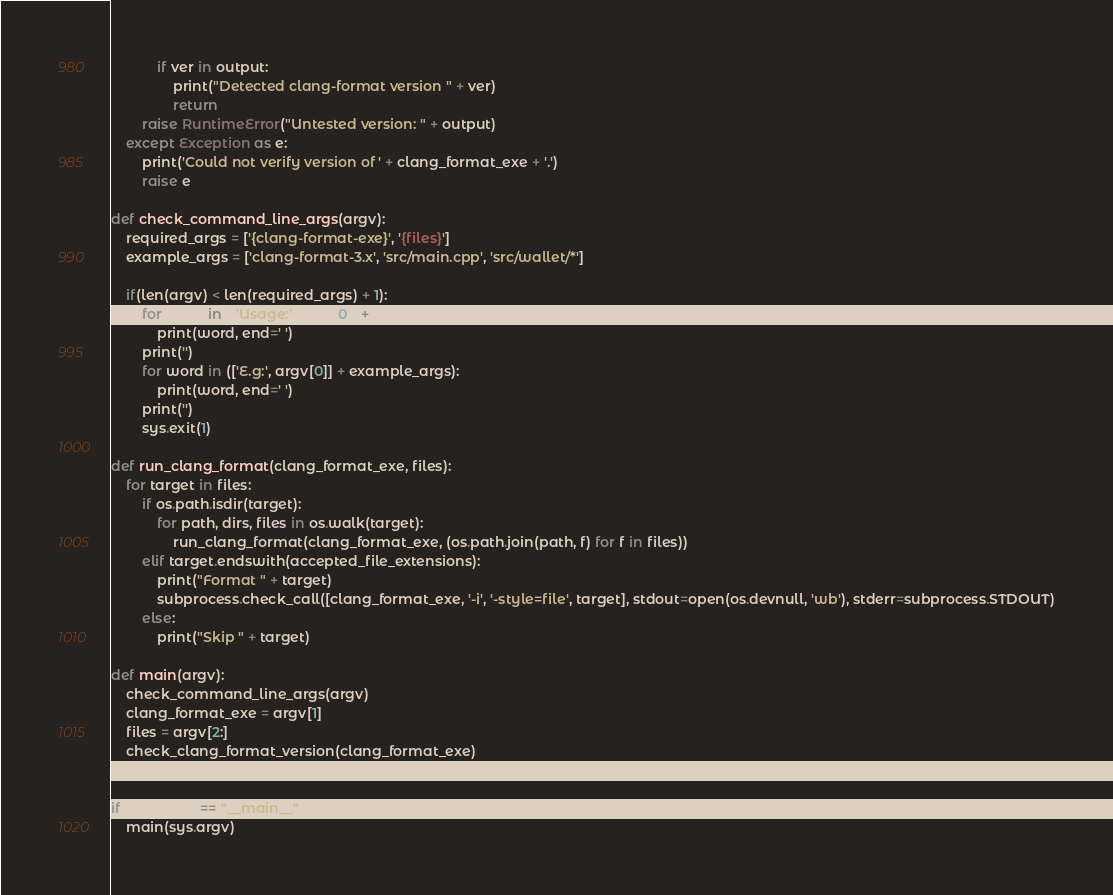Convert code to text. <code><loc_0><loc_0><loc_500><loc_500><_Python_>            if ver in output:
                print("Detected clang-format version " + ver)
                return
        raise RuntimeError("Untested version: " + output)
    except Exception as e:
        print('Could not verify version of ' + clang_format_exe + '.')
        raise e

def check_command_line_args(argv):
    required_args = ['{clang-format-exe}', '{files}']
    example_args = ['clang-format-3.x', 'src/main.cpp', 'src/wallet/*']

    if(len(argv) < len(required_args) + 1):
        for word in (['Usage:', argv[0]] + required_args):
            print(word, end=' ')
        print('')
        for word in (['E.g:', argv[0]] + example_args):
            print(word, end=' ')
        print('')
        sys.exit(1)

def run_clang_format(clang_format_exe, files):
    for target in files:
        if os.path.isdir(target):
            for path, dirs, files in os.walk(target):
                run_clang_format(clang_format_exe, (os.path.join(path, f) for f in files))
        elif target.endswith(accepted_file_extensions):
            print("Format " + target)
            subprocess.check_call([clang_format_exe, '-i', '-style=file', target], stdout=open(os.devnull, 'wb'), stderr=subprocess.STDOUT)
        else:
            print("Skip " + target)

def main(argv):
    check_command_line_args(argv)
    clang_format_exe = argv[1]
    files = argv[2:]
    check_clang_format_version(clang_format_exe)
    run_clang_format(clang_format_exe, files)

if __name__ == "__main__":
    main(sys.argv)
</code> 